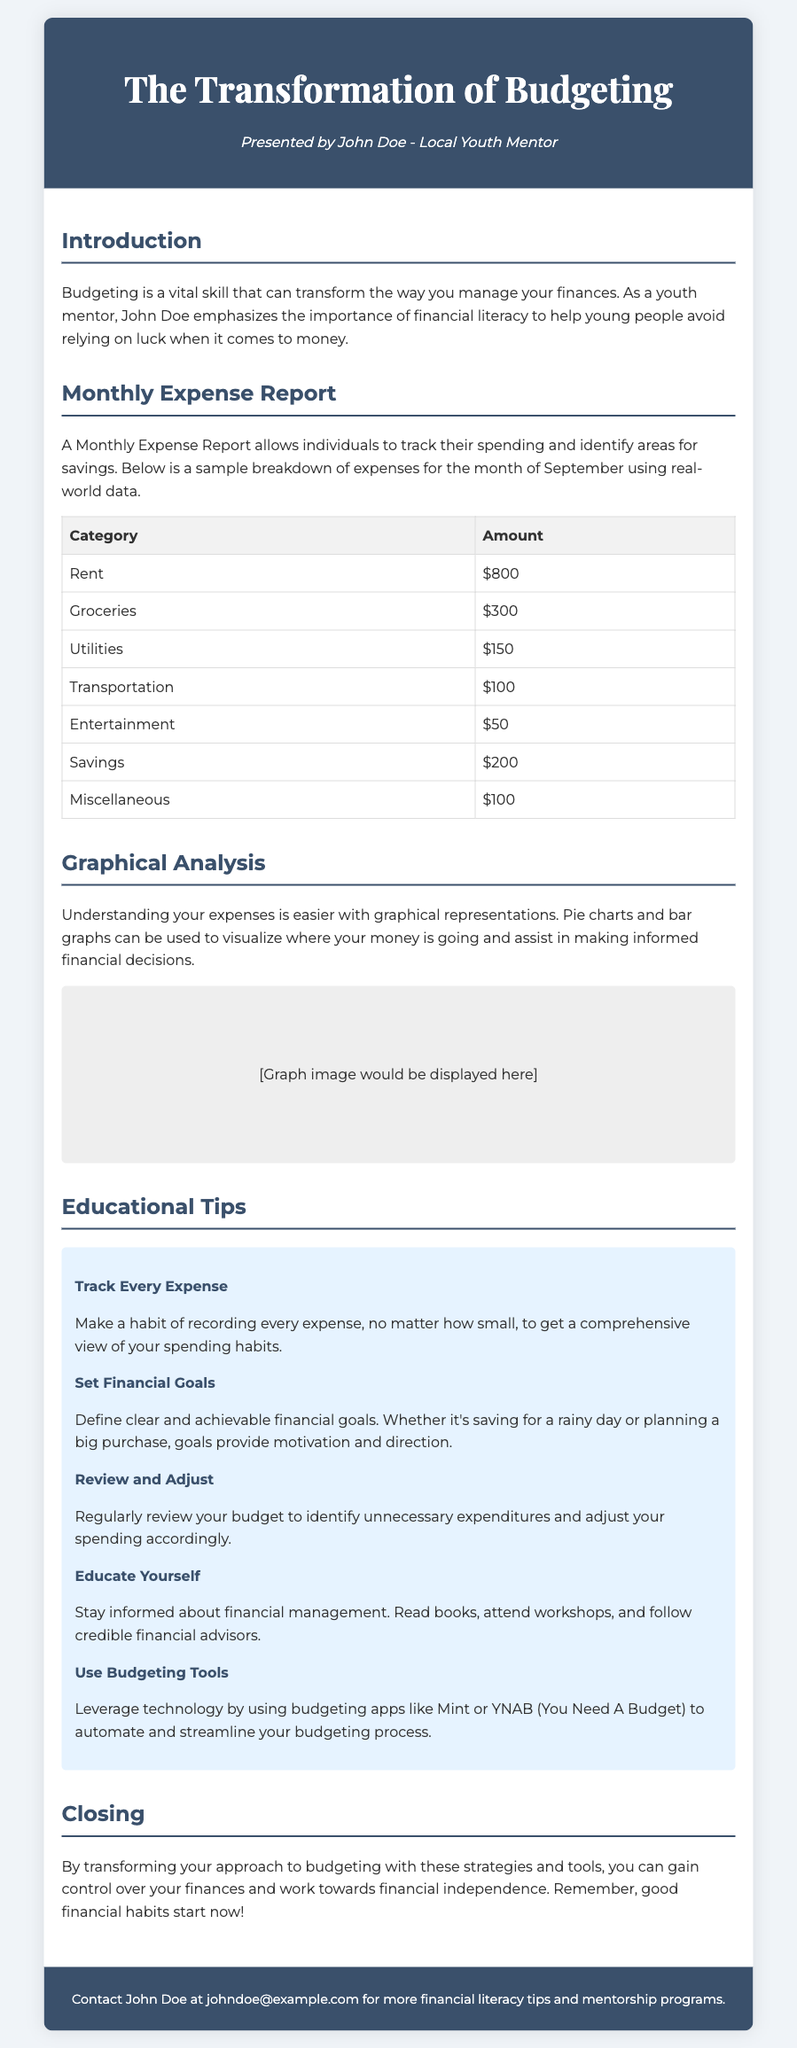What is the main purpose of the document? The document aims to educate individuals about budgeting and financial literacy to avoid reliance on luck.
Answer: Educate about budgeting How much is allocated for Rent? The Rent amount in the Monthly Expense Report is listed in the expense table under the Rent category.
Answer: $800 What category has the lowest expense? To determine the lowest expense, we compare all amounts in the expense table.
Answer: Entertainment What is the total amount allocated for Savings? The Savings amount is explicitly stated in the table under the Savings category.
Answer: $200 Which section emphasizes tracking every expense? The section that provides tips includes a focus on tracking expenses.
Answer: Educational Tips How many tips are provided in the document? The document lists several tips within the Educational Tips section.
Answer: Five What is the color of the header background? The header background color is specified in the style section of the document.
Answer: Dark blue Which budgeting app is mentioned as a tool? The document highlights a specific app that can be used for budgeting.
Answer: Mint What is the contact email for John Doe? The contact email for John Doe is provided in the footer of the document.
Answer: johndoe@example.com 